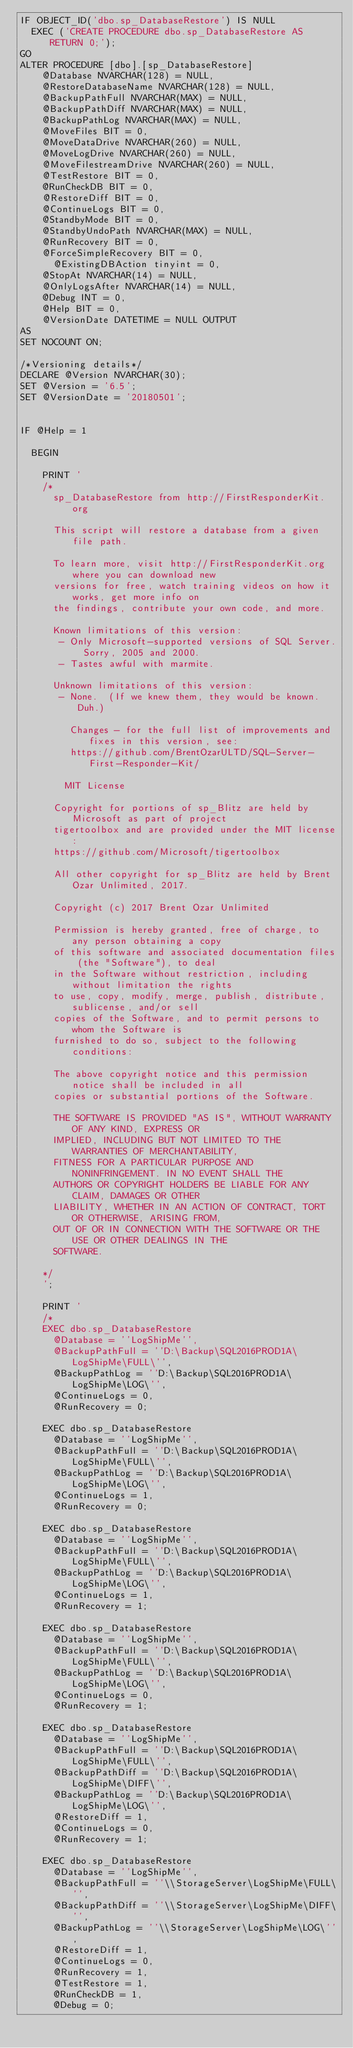Convert code to text. <code><loc_0><loc_0><loc_500><loc_500><_SQL_>IF OBJECT_ID('dbo.sp_DatabaseRestore') IS NULL
	EXEC ('CREATE PROCEDURE dbo.sp_DatabaseRestore AS RETURN 0;');
GO
ALTER PROCEDURE [dbo].[sp_DatabaseRestore]
	  @Database NVARCHAR(128) = NULL, 
	  @RestoreDatabaseName NVARCHAR(128) = NULL, 
	  @BackupPathFull NVARCHAR(MAX) = NULL, 
	  @BackupPathDiff NVARCHAR(MAX) = NULL, 
	  @BackupPathLog NVARCHAR(MAX) = NULL,
	  @MoveFiles BIT = 0, 
	  @MoveDataDrive NVARCHAR(260) = NULL, 
	  @MoveLogDrive NVARCHAR(260) = NULL, 
	  @MoveFilestreamDrive NVARCHAR(260) = NULL,
	  @TestRestore BIT = 0, 
	  @RunCheckDB BIT = 0, 
	  @RestoreDiff BIT = 0,
	  @ContinueLogs BIT = 0, 
	  @StandbyMode BIT = 0,
	  @StandbyUndoPath NVARCHAR(MAX) = NULL,
	  @RunRecovery BIT = 0, 
	  @ForceSimpleRecovery BIT = 0,
      @ExistingDBAction tinyint = 0,
	  @StopAt NVARCHAR(14) = NULL,
	  @OnlyLogsAfter NVARCHAR(14) = NULL,
	  @Debug INT = 0, 
	  @Help BIT = 0,
	  @VersionDate DATETIME = NULL OUTPUT
AS
SET NOCOUNT ON;

/*Versioning details*/
DECLARE @Version NVARCHAR(30);
SET @Version = '6.5';
SET @VersionDate = '20180501';


IF @Help = 1

	BEGIN
	
		PRINT '
		/*
			sp_DatabaseRestore from http://FirstResponderKit.org
			
			This script will restore a database from a given file path.
		
			To learn more, visit http://FirstResponderKit.org where you can download new
			versions for free, watch training videos on how it works, get more info on
			the findings, contribute your own code, and more.
		
			Known limitations of this version:
			 - Only Microsoft-supported versions of SQL Server. Sorry, 2005 and 2000.
			 - Tastes awful with marmite.
		
			Unknown limitations of this version:
			 - None.  (If we knew them, they would be known. Duh.)
		
		     Changes - for the full list of improvements and fixes in this version, see:
		     https://github.com/BrentOzarULTD/SQL-Server-First-Responder-Kit/
		
		    MIT License
			
			Copyright for portions of sp_Blitz are held by Microsoft as part of project 
			tigertoolbox and are provided under the MIT license:
			https://github.com/Microsoft/tigertoolbox
			   
			All other copyright for sp_Blitz are held by Brent Ozar Unlimited, 2017.
		
			Copyright (c) 2017 Brent Ozar Unlimited
		
			Permission is hereby granted, free of charge, to any person obtaining a copy
			of this software and associated documentation files (the "Software"), to deal
			in the Software without restriction, including without limitation the rights
			to use, copy, modify, merge, publish, distribute, sublicense, and/or sell
			copies of the Software, and to permit persons to whom the Software is
			furnished to do so, subject to the following conditions:
		
			The above copyright notice and this permission notice shall be included in all
			copies or substantial portions of the Software.
		
			THE SOFTWARE IS PROVIDED "AS IS", WITHOUT WARRANTY OF ANY KIND, EXPRESS OR
			IMPLIED, INCLUDING BUT NOT LIMITED TO THE WARRANTIES OF MERCHANTABILITY,
			FITNESS FOR A PARTICULAR PURPOSE AND NONINFRINGEMENT. IN NO EVENT SHALL THE
			AUTHORS OR COPYRIGHT HOLDERS BE LIABLE FOR ANY CLAIM, DAMAGES OR OTHER
			LIABILITY, WHETHER IN AN ACTION OF CONTRACT, TORT OR OTHERWISE, ARISING FROM,
			OUT OF OR IN CONNECTION WITH THE SOFTWARE OR THE USE OR OTHER DEALINGS IN THE
			SOFTWARE.
		
		*/
		';
		
		PRINT '
		/*
		EXEC dbo.sp_DatabaseRestore 
			@Database = ''LogShipMe'', 
			@BackupPathFull = ''D:\Backup\SQL2016PROD1A\LogShipMe\FULL\'', 
			@BackupPathLog = ''D:\Backup\SQL2016PROD1A\LogShipMe\LOG\'', 
			@ContinueLogs = 0, 
			@RunRecovery = 0;
		
		EXEC dbo.sp_DatabaseRestore 
			@Database = ''LogShipMe'', 
			@BackupPathFull = ''D:\Backup\SQL2016PROD1A\LogShipMe\FULL\'', 
			@BackupPathLog = ''D:\Backup\SQL2016PROD1A\LogShipMe\LOG\'', 
			@ContinueLogs = 1, 
			@RunRecovery = 0;
		
		EXEC dbo.sp_DatabaseRestore 
			@Database = ''LogShipMe'', 
			@BackupPathFull = ''D:\Backup\SQL2016PROD1A\LogShipMe\FULL\'', 
			@BackupPathLog = ''D:\Backup\SQL2016PROD1A\LogShipMe\LOG\'', 
			@ContinueLogs = 1, 
			@RunRecovery = 1;
		
		EXEC dbo.sp_DatabaseRestore 
			@Database = ''LogShipMe'', 
			@BackupPathFull = ''D:\Backup\SQL2016PROD1A\LogShipMe\FULL\'', 
			@BackupPathLog = ''D:\Backup\SQL2016PROD1A\LogShipMe\LOG\'', 
			@ContinueLogs = 0, 
			@RunRecovery = 1;
		
		EXEC dbo.sp_DatabaseRestore 
			@Database = ''LogShipMe'', 
			@BackupPathFull = ''D:\Backup\SQL2016PROD1A\LogShipMe\FULL\'', 
			@BackupPathDiff = ''D:\Backup\SQL2016PROD1A\LogShipMe\DIFF\'',
			@BackupPathLog = ''D:\Backup\SQL2016PROD1A\LogShipMe\LOG\'', 
			@RestoreDiff = 1,
			@ContinueLogs = 0, 
			@RunRecovery = 1;
		 
		EXEC dbo.sp_DatabaseRestore 
			@Database = ''LogShipMe'', 
			@BackupPathFull = ''\\StorageServer\LogShipMe\FULL\'', 
			@BackupPathDiff = ''\\StorageServer\LogShipMe\DIFF\'',
			@BackupPathLog = ''\\StorageServer\LogShipMe\LOG\'', 
			@RestoreDiff = 1,
			@ContinueLogs = 0, 
			@RunRecovery = 1,
			@TestRestore = 1,
			@RunCheckDB = 1,
			@Debug = 0;
</code> 